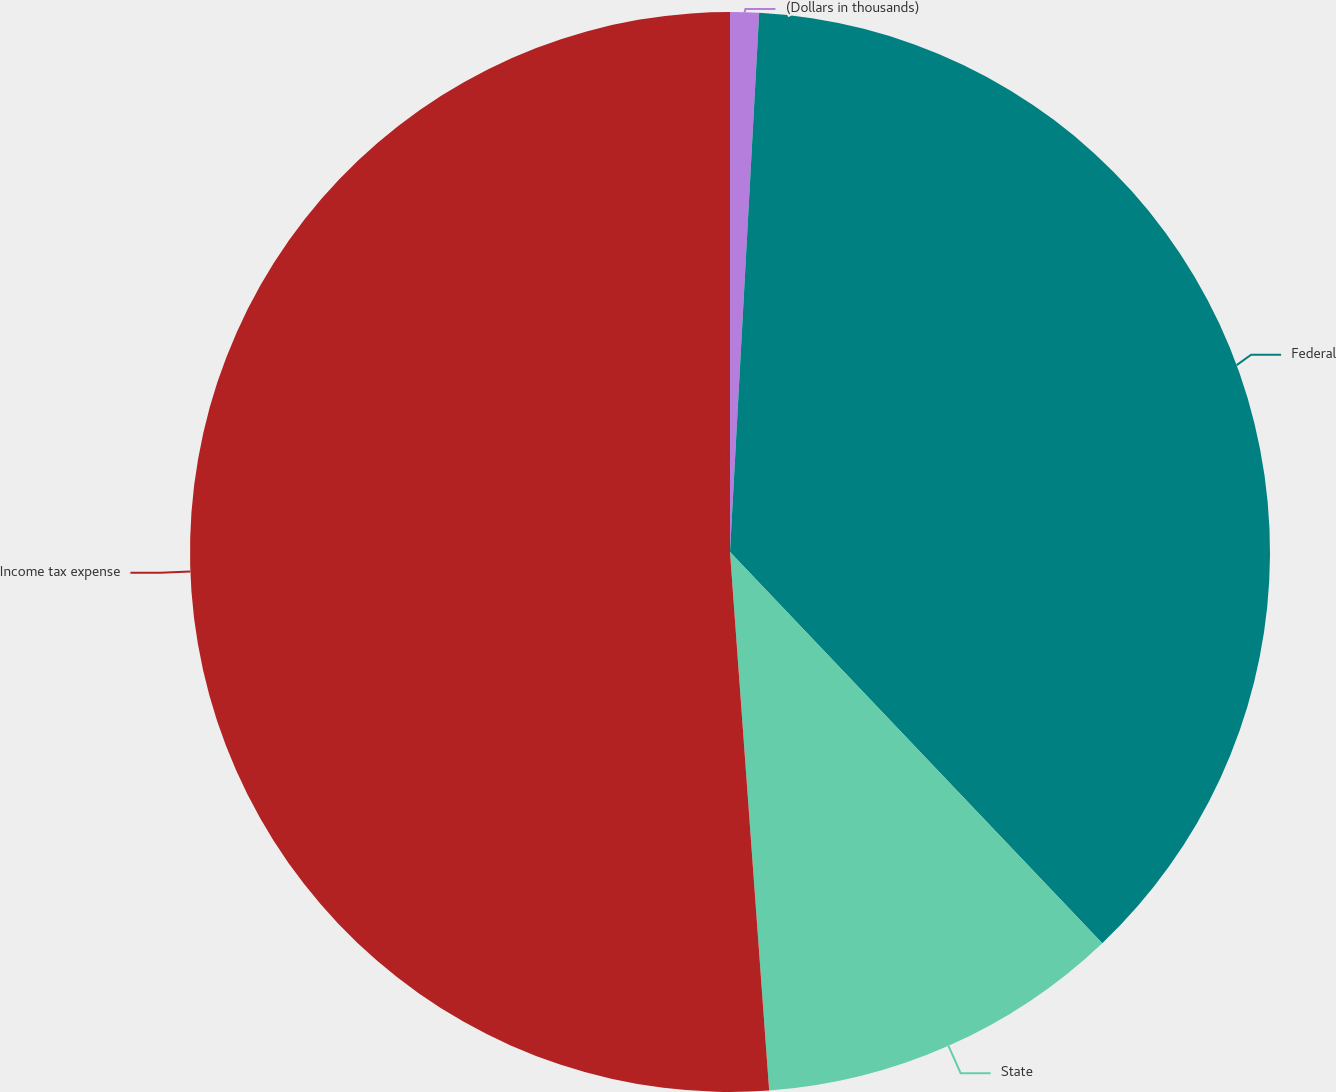Convert chart. <chart><loc_0><loc_0><loc_500><loc_500><pie_chart><fcel>(Dollars in thousands)<fcel>Federal<fcel>State<fcel>Income tax expense<nl><fcel>0.86%<fcel>37.03%<fcel>10.95%<fcel>51.15%<nl></chart> 